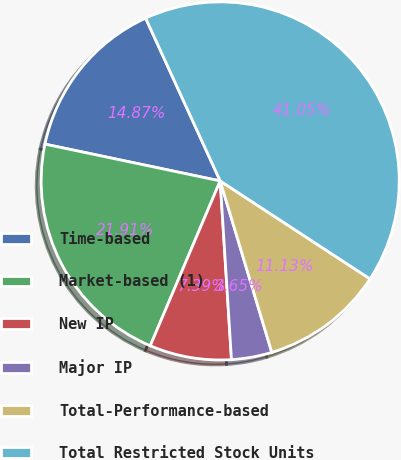Convert chart to OTSL. <chart><loc_0><loc_0><loc_500><loc_500><pie_chart><fcel>Time-based<fcel>Market-based (1)<fcel>New IP<fcel>Major IP<fcel>Total-Performance-based<fcel>Total Restricted Stock Units<nl><fcel>14.87%<fcel>21.91%<fcel>7.39%<fcel>3.65%<fcel>11.13%<fcel>41.05%<nl></chart> 